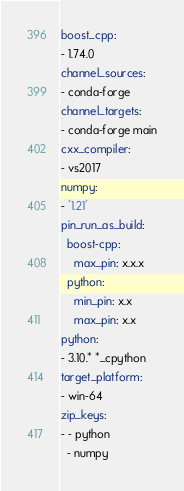Convert code to text. <code><loc_0><loc_0><loc_500><loc_500><_YAML_>boost_cpp:
- 1.74.0
channel_sources:
- conda-forge
channel_targets:
- conda-forge main
cxx_compiler:
- vs2017
numpy:
- '1.21'
pin_run_as_build:
  boost-cpp:
    max_pin: x.x.x
  python:
    min_pin: x.x
    max_pin: x.x
python:
- 3.10.* *_cpython
target_platform:
- win-64
zip_keys:
- - python
  - numpy
</code> 